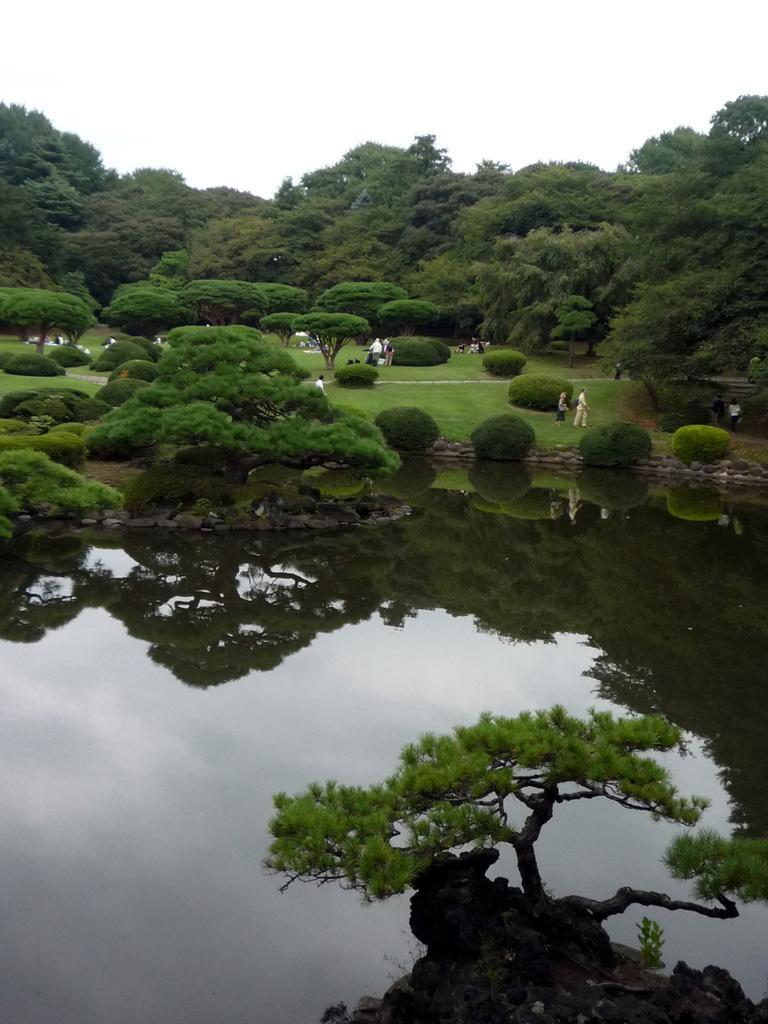Could you give a brief overview of what you see in this image? In this picture there is water in the center of the image and there is greenery at the top side of the image, there are people on the grassland. 